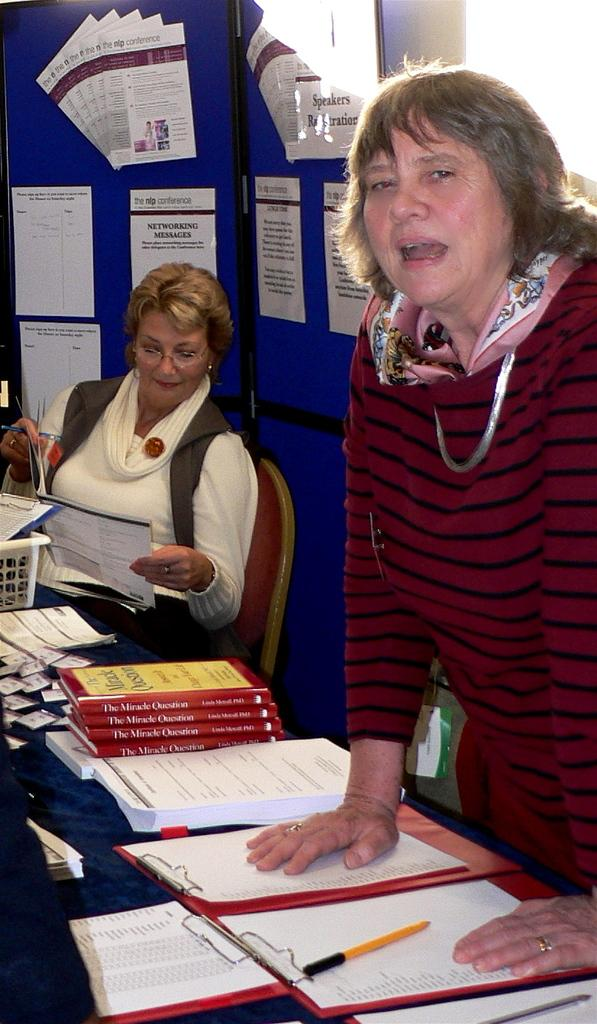<image>
Render a clear and concise summary of the photo. A stack of books called The Miracle Question sitting on a desk. 